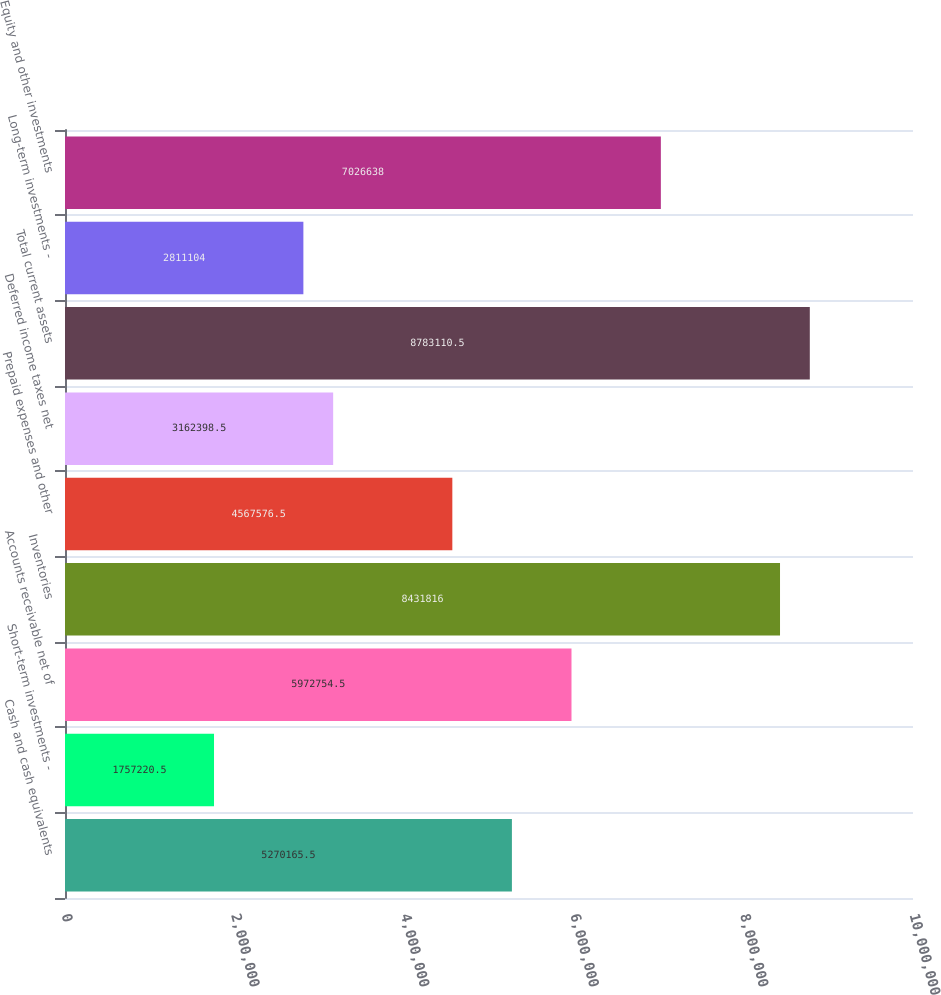Convert chart to OTSL. <chart><loc_0><loc_0><loc_500><loc_500><bar_chart><fcel>Cash and cash equivalents<fcel>Short-term investments -<fcel>Accounts receivable net of<fcel>Inventories<fcel>Prepaid expenses and other<fcel>Deferred income taxes net<fcel>Total current assets<fcel>Long-term investments -<fcel>Equity and other investments<nl><fcel>5.27017e+06<fcel>1.75722e+06<fcel>5.97275e+06<fcel>8.43182e+06<fcel>4.56758e+06<fcel>3.1624e+06<fcel>8.78311e+06<fcel>2.8111e+06<fcel>7.02664e+06<nl></chart> 